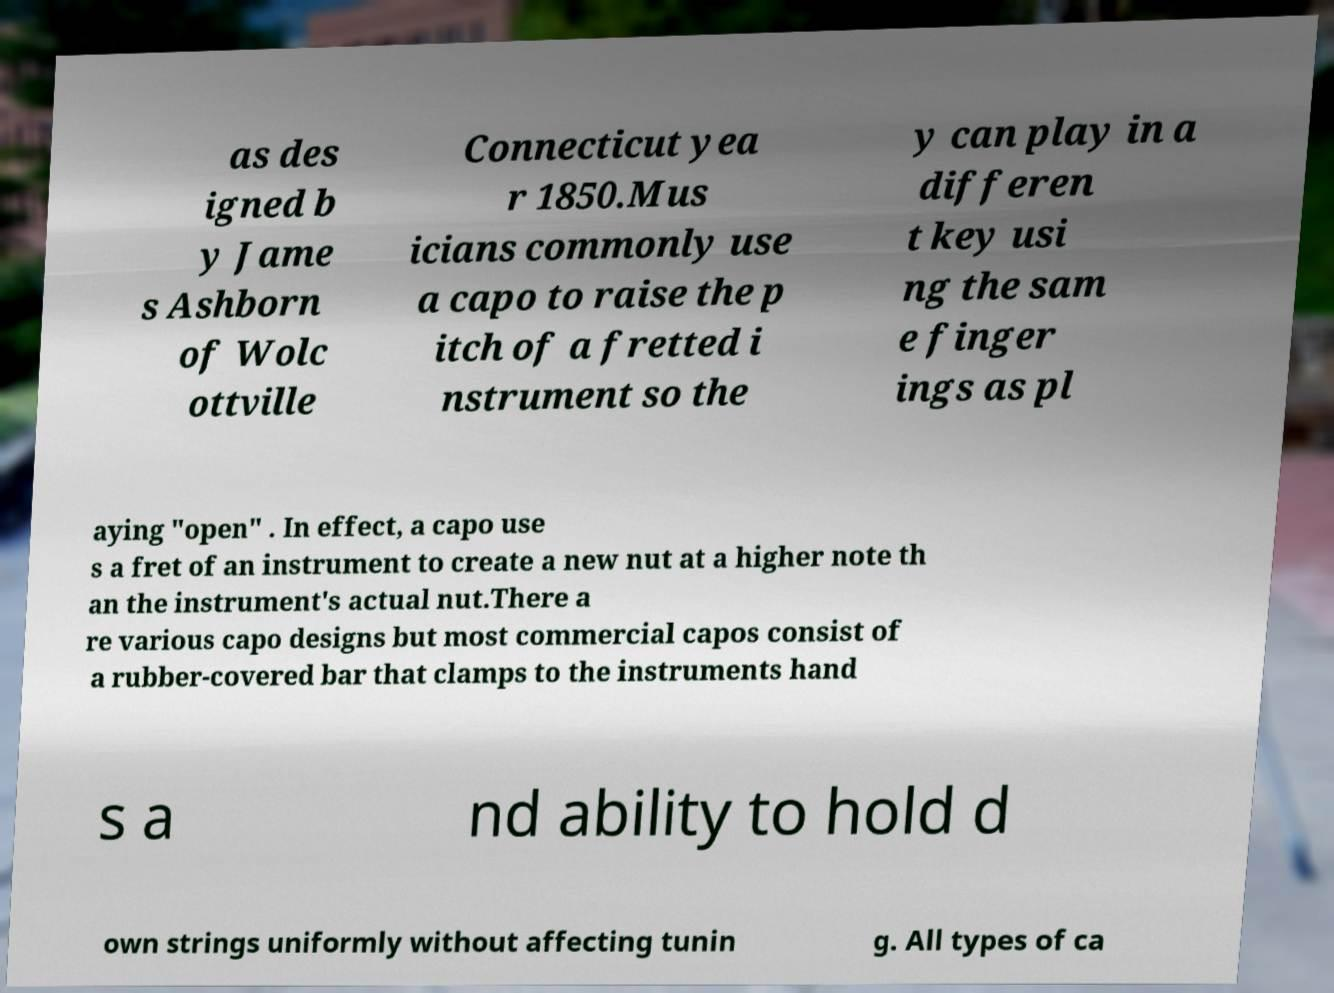For documentation purposes, I need the text within this image transcribed. Could you provide that? as des igned b y Jame s Ashborn of Wolc ottville Connecticut yea r 1850.Mus icians commonly use a capo to raise the p itch of a fretted i nstrument so the y can play in a differen t key usi ng the sam e finger ings as pl aying "open" . In effect, a capo use s a fret of an instrument to create a new nut at a higher note th an the instrument's actual nut.There a re various capo designs but most commercial capos consist of a rubber-covered bar that clamps to the instruments hand s a nd ability to hold d own strings uniformly without affecting tunin g. All types of ca 